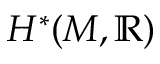<formula> <loc_0><loc_0><loc_500><loc_500>H ^ { * } ( M , \mathbb { R } )</formula> 